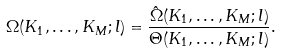Convert formula to latex. <formula><loc_0><loc_0><loc_500><loc_500>\Omega ( K _ { 1 } , \dots , K _ { M } ; l ) = \frac { \hat { \Omega } ( K _ { 1 } , \dots , K _ { M } ; l ) } { \Theta ( K _ { 1 } , \dots , K _ { M } ; l ) } .</formula> 